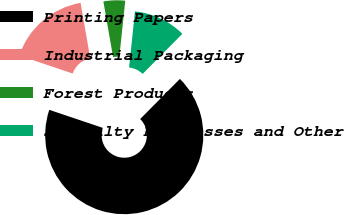Convert chart to OTSL. <chart><loc_0><loc_0><loc_500><loc_500><pie_chart><fcel>Printing Papers<fcel>Industrial Packaging<fcel>Forest Products<fcel>Specialty Businesses and Other<nl><fcel>67.75%<fcel>17.08%<fcel>4.42%<fcel>10.75%<nl></chart> 